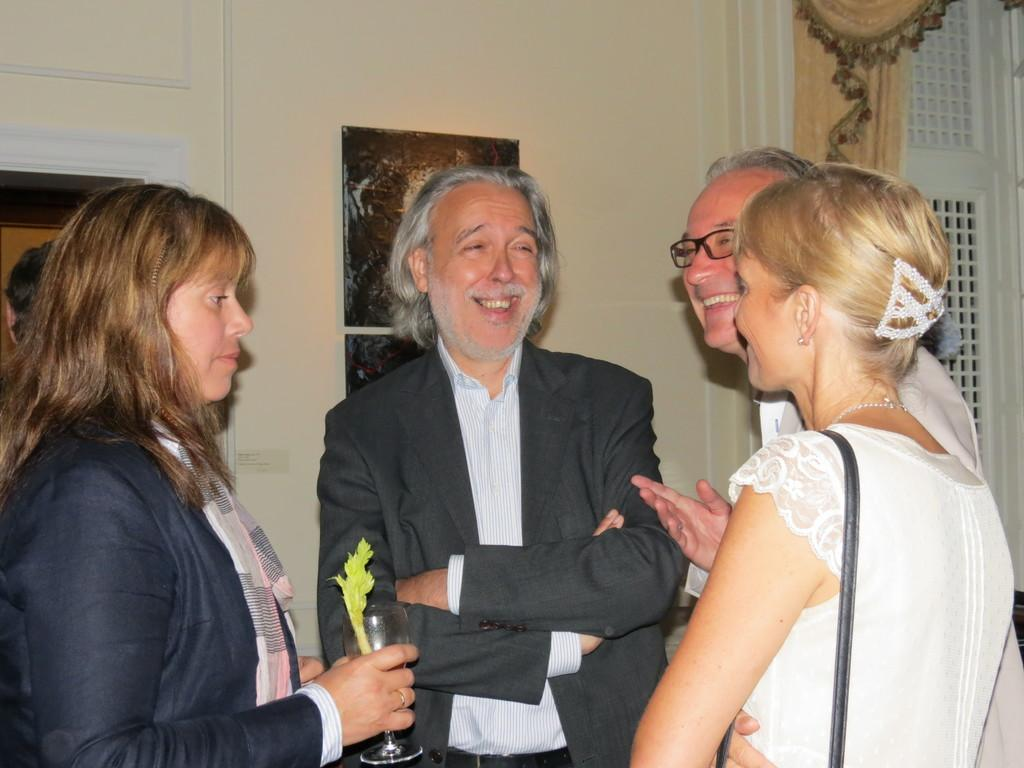What is happening in the center of the image? There are persons standing in the center of the image. What surface are the persons standing on? The persons are standing on the floor. What can be seen in the background of the image? There are photo frames, a door, a curtain associated with a window, and windows in the background of the image. Can you see a robin taking a bath in the image? There is no robin or bath present in the image. What type of rat is hiding behind the door in the image? There is no rat present in the image; the image only features persons standing on the floor and background elements. 